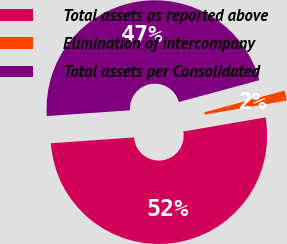<chart> <loc_0><loc_0><loc_500><loc_500><pie_chart><fcel>Total assets as reported above<fcel>Elimination of intercompany<fcel>Total assets per Consolidated<nl><fcel>51.59%<fcel>1.51%<fcel>46.9%<nl></chart> 